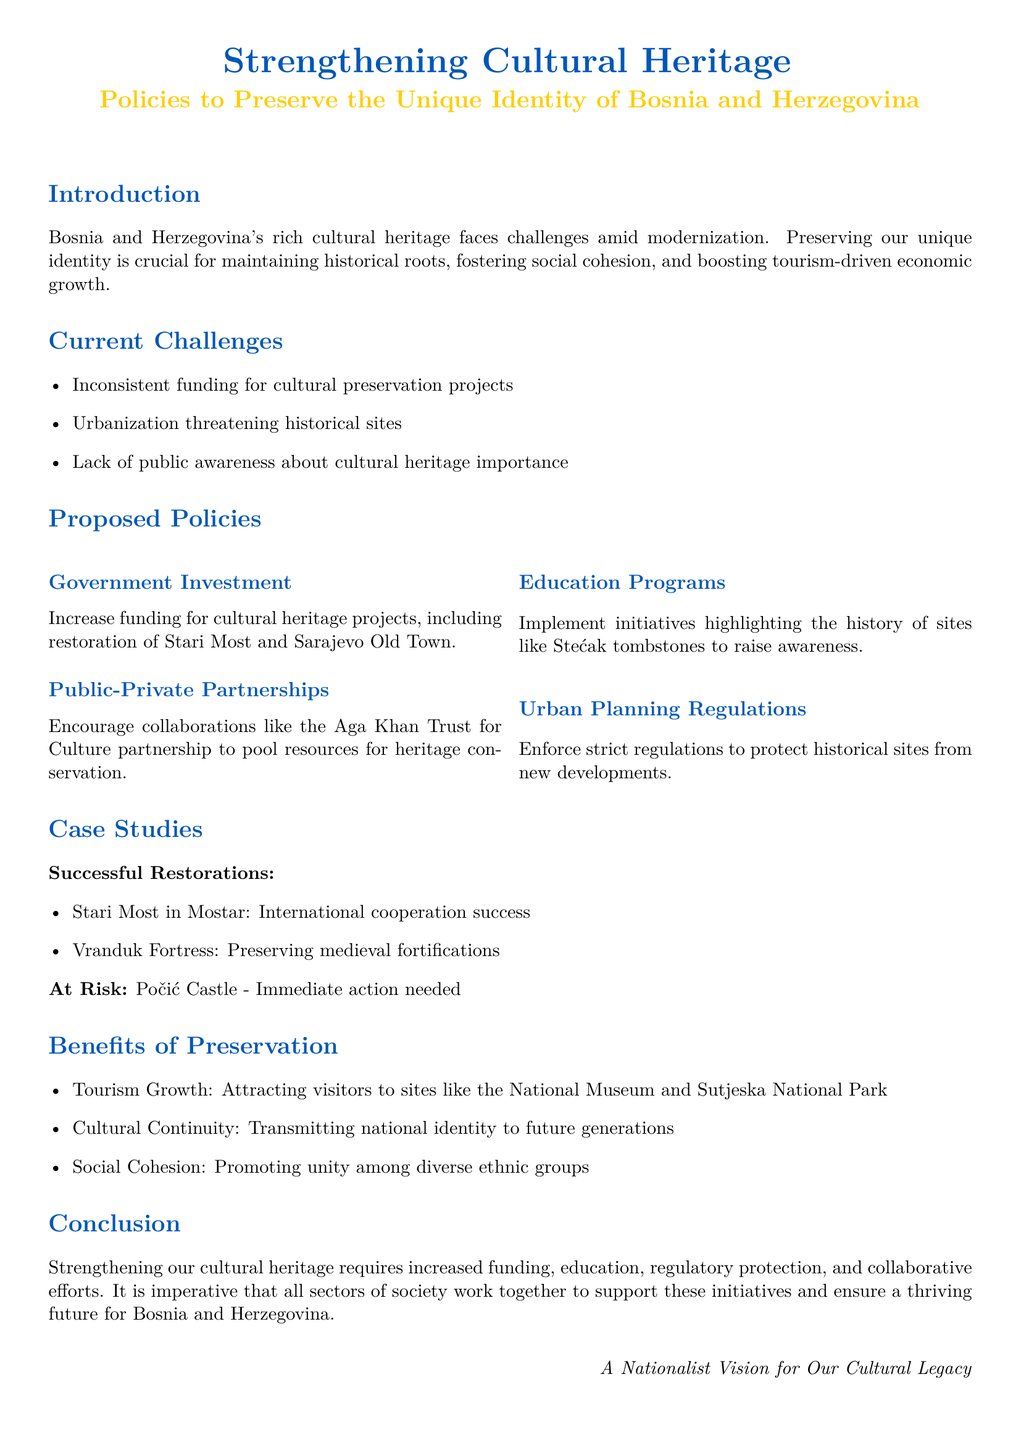What are the primary challenges faced in cultural heritage preservation? The challenges listed in the document include inconsistent funding for cultural preservation projects, urbanization threatening historical sites, and lack of public awareness about cultural heritage importance.
Answer: inconsistent funding, urbanization, lack of public awareness What is one example of a historical site with successful restoration? The document mentions Stari Most in Mostar as a success story of international cooperation for restoration.
Answer: Stari Most What are the proposed policies to strengthen cultural heritage? The policies include increasing government investment, encouraging public-private partnerships, implementing education programs, and enforcing urban planning regulations.
Answer: Government Investment, Public-Private Partnerships, Education Programs, Urban Planning Regulations Which fortress is mentioned as preserving medieval fortifications? The document cites Vranduk Fortress as an example of a successful preservation of medieval fortifications.
Answer: Vranduk Fortress What benefits are associated with the preservation of cultural heritage? Benefits listed in the document include tourism growth, cultural continuity, and social cohesion.
Answer: tourism growth, cultural continuity, social cohesion What is the immediate action needed for Počić Castle? The document indicates that Počić Castle is at risk and requires immediate action to prevent further deterioration.
Answer: immediate action needed What color represents the headings in the document? The headings are represented in a specific blue color defined as 'bosniablue'.
Answer: bosniablue What is the central focus of this whitepaper? The focus of the whitepaper is on policies to preserve the unique identity of Bosnia and Herzegovina through cultural heritage.
Answer: preserving unique identity What is a specific cultural site mentioned that will attract tourism? The document mentions the National Museum as a site that can attract visitors for tourism.
Answer: National Museum 